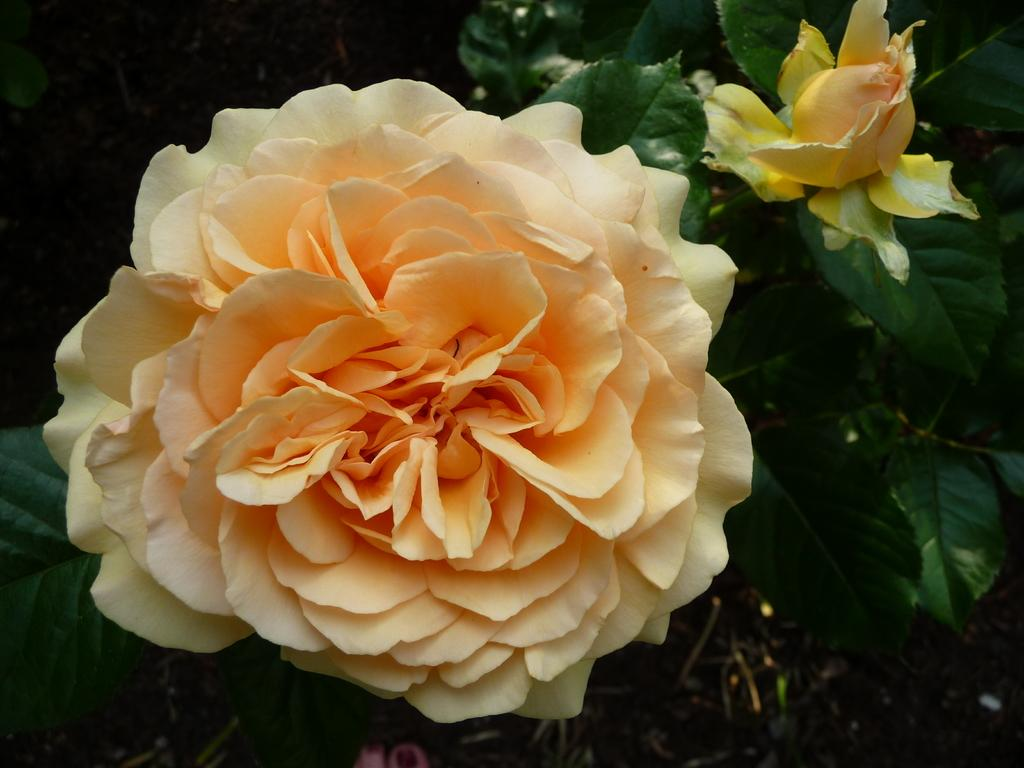How many flowers can be seen in the image? There are two flowers in the image. What else can be seen in the image besides the flowers? There are leaves in the image. What is the color of the background in the image? The background of the image is dark. Is there a stamp on the flowers in the image? There is no stamp present on the flowers in the image. Can you see an airport in the background of the image? There is no airport visible in the image; the background is dark and does not show any buildings or structures. 